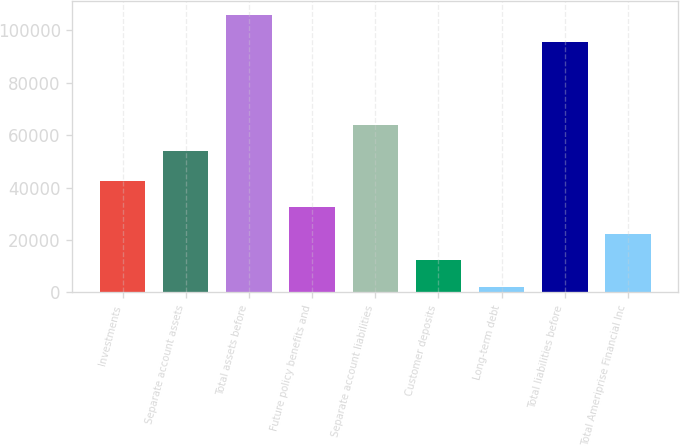Convert chart to OTSL. <chart><loc_0><loc_0><loc_500><loc_500><bar_chart><fcel>Investments<fcel>Separate account assets<fcel>Total assets before<fcel>Future policy benefits and<fcel>Separate account liabilities<fcel>Customer deposits<fcel>Long-term debt<fcel>Total liabilities before<fcel>Total Ameriprise Financial Inc<nl><fcel>42612.2<fcel>53848<fcel>105805<fcel>32463.9<fcel>63996.3<fcel>12167.3<fcel>2019<fcel>95657<fcel>22315.6<nl></chart> 